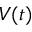Convert formula to latex. <formula><loc_0><loc_0><loc_500><loc_500>V ( t )</formula> 